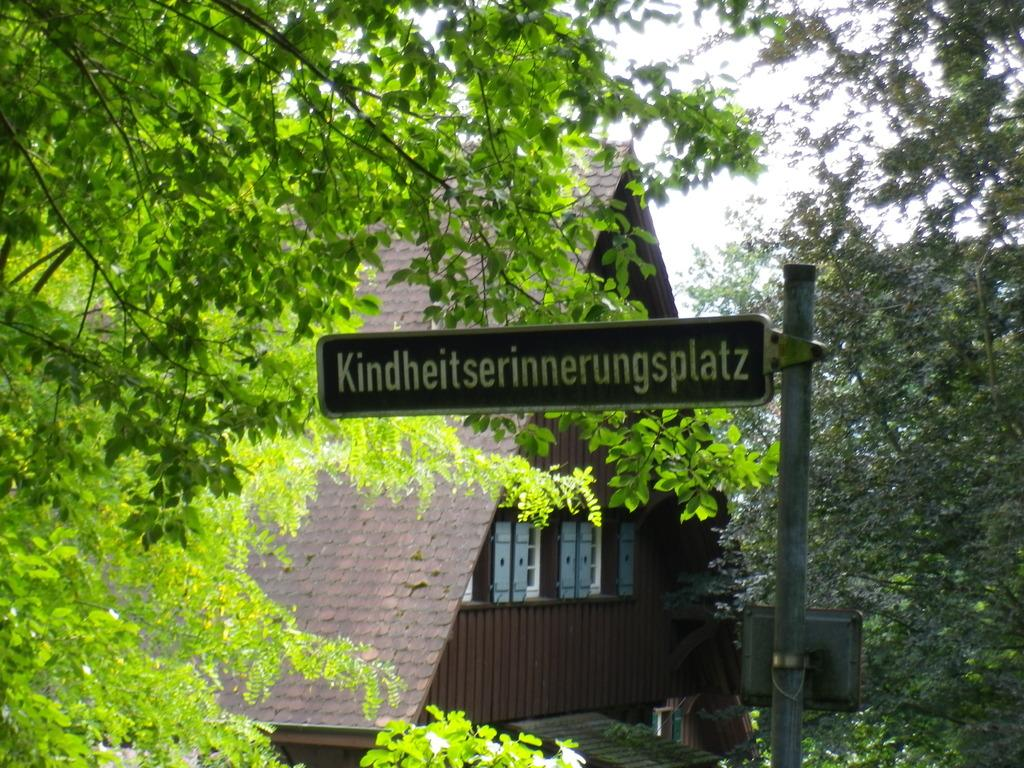What type of structure is present in the image? There is a shed in the image. What other natural elements can be seen in the image? There are trees in the image. Can you describe any man-made objects in the image? There is a board in the image. What is visible at the top of the image? The sky is visible at the top of the image. What type of vegetation is present in the bottom right corner of the image? There are plants in the bottom right corner of the image. How many turkeys can be observed in the image? There are no turkeys present in the image. What is the amount of observation required to see the plants in the bottom right corner of the image? The question is unclear and seems to be asking about the level of observation needed to see the plants, which is not relevant to the image. The plants are clearly visible in the bottom right corner of the image. 